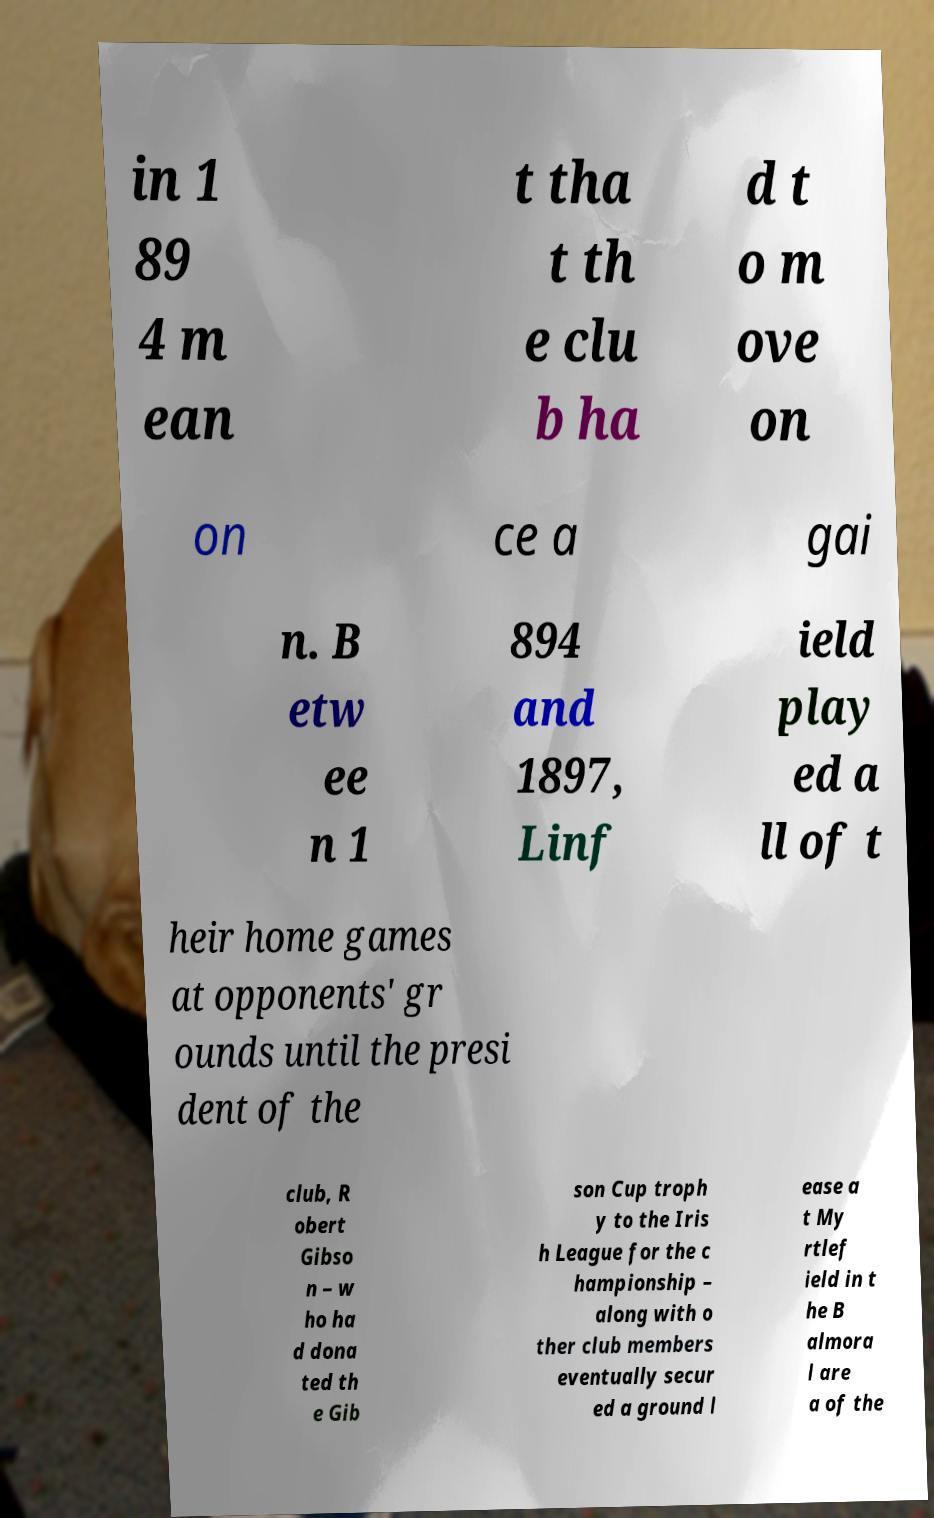For documentation purposes, I need the text within this image transcribed. Could you provide that? in 1 89 4 m ean t tha t th e clu b ha d t o m ove on on ce a gai n. B etw ee n 1 894 and 1897, Linf ield play ed a ll of t heir home games at opponents' gr ounds until the presi dent of the club, R obert Gibso n – w ho ha d dona ted th e Gib son Cup troph y to the Iris h League for the c hampionship – along with o ther club members eventually secur ed a ground l ease a t My rtlef ield in t he B almora l are a of the 